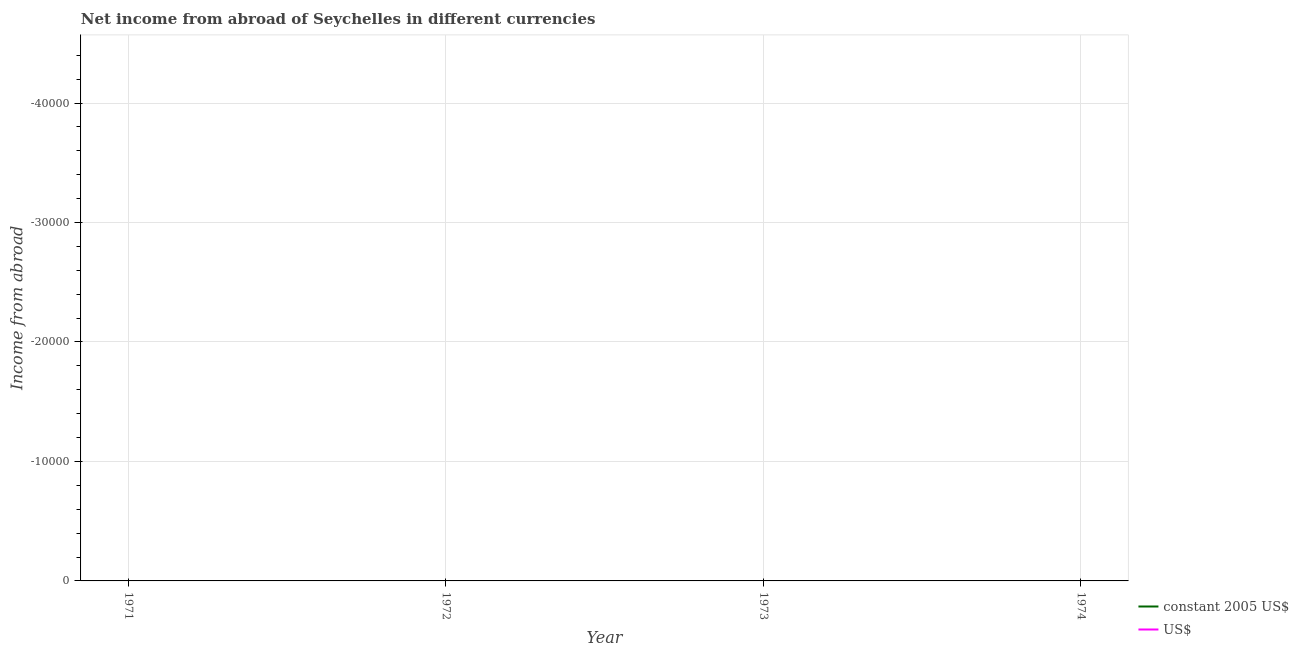How many different coloured lines are there?
Make the answer very short. 0. Across all years, what is the minimum income from abroad in constant 2005 us$?
Offer a terse response. 0. What is the total income from abroad in us$ in the graph?
Keep it short and to the point. 0. What is the difference between the income from abroad in constant 2005 us$ in 1972 and the income from abroad in us$ in 1973?
Ensure brevity in your answer.  0. In how many years, is the income from abroad in us$ greater than the average income from abroad in us$ taken over all years?
Your response must be concise. 0. Does the income from abroad in us$ monotonically increase over the years?
Your response must be concise. No. Is the income from abroad in us$ strictly less than the income from abroad in constant 2005 us$ over the years?
Keep it short and to the point. No. How many years are there in the graph?
Your response must be concise. 4. What is the difference between two consecutive major ticks on the Y-axis?
Your answer should be compact. 10000. Does the graph contain grids?
Give a very brief answer. Yes. Where does the legend appear in the graph?
Give a very brief answer. Bottom right. What is the title of the graph?
Your answer should be very brief. Net income from abroad of Seychelles in different currencies. Does "Borrowers" appear as one of the legend labels in the graph?
Provide a succinct answer. No. What is the label or title of the X-axis?
Your answer should be compact. Year. What is the label or title of the Y-axis?
Your response must be concise. Income from abroad. What is the Income from abroad in constant 2005 US$ in 1971?
Provide a succinct answer. 0. What is the Income from abroad of US$ in 1971?
Keep it short and to the point. 0. What is the Income from abroad of constant 2005 US$ in 1972?
Your answer should be very brief. 0. What is the Income from abroad of constant 2005 US$ in 1974?
Your answer should be compact. 0. What is the total Income from abroad of US$ in the graph?
Make the answer very short. 0. What is the average Income from abroad in constant 2005 US$ per year?
Your answer should be compact. 0. 